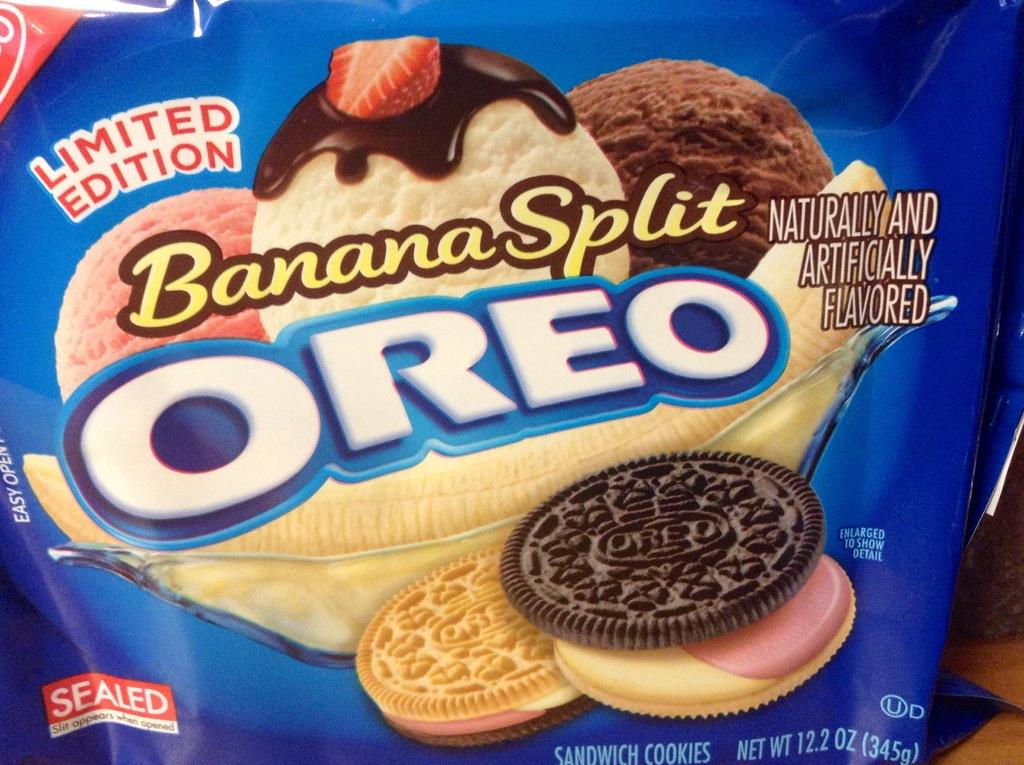What type of food is contained in the food packet in the image? The food packet contains ice cream scoops and cream biscuits. What color is the apple in the image? There is no apple present in the image. 